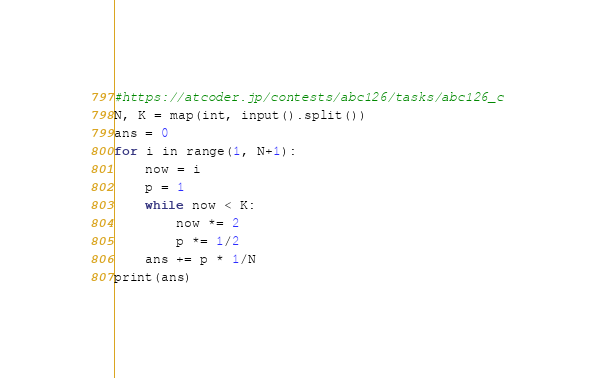Convert code to text. <code><loc_0><loc_0><loc_500><loc_500><_Python_>#https://atcoder.jp/contests/abc126/tasks/abc126_c
N, K = map(int, input().split())
ans = 0
for i in range(1, N+1):
    now = i
    p = 1
    while now < K:
        now *= 2
        p *= 1/2
    ans += p * 1/N  
print(ans)


</code> 